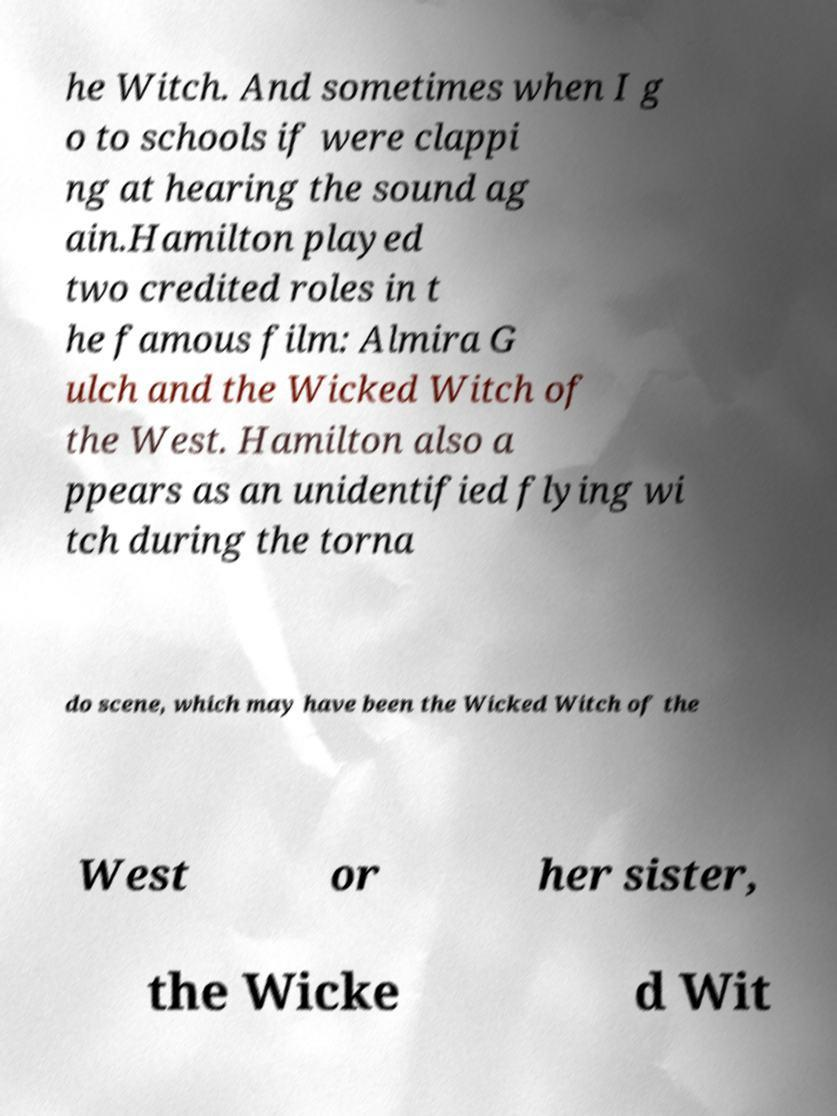Please read and relay the text visible in this image. What does it say? he Witch. And sometimes when I g o to schools if were clappi ng at hearing the sound ag ain.Hamilton played two credited roles in t he famous film: Almira G ulch and the Wicked Witch of the West. Hamilton also a ppears as an unidentified flying wi tch during the torna do scene, which may have been the Wicked Witch of the West or her sister, the Wicke d Wit 